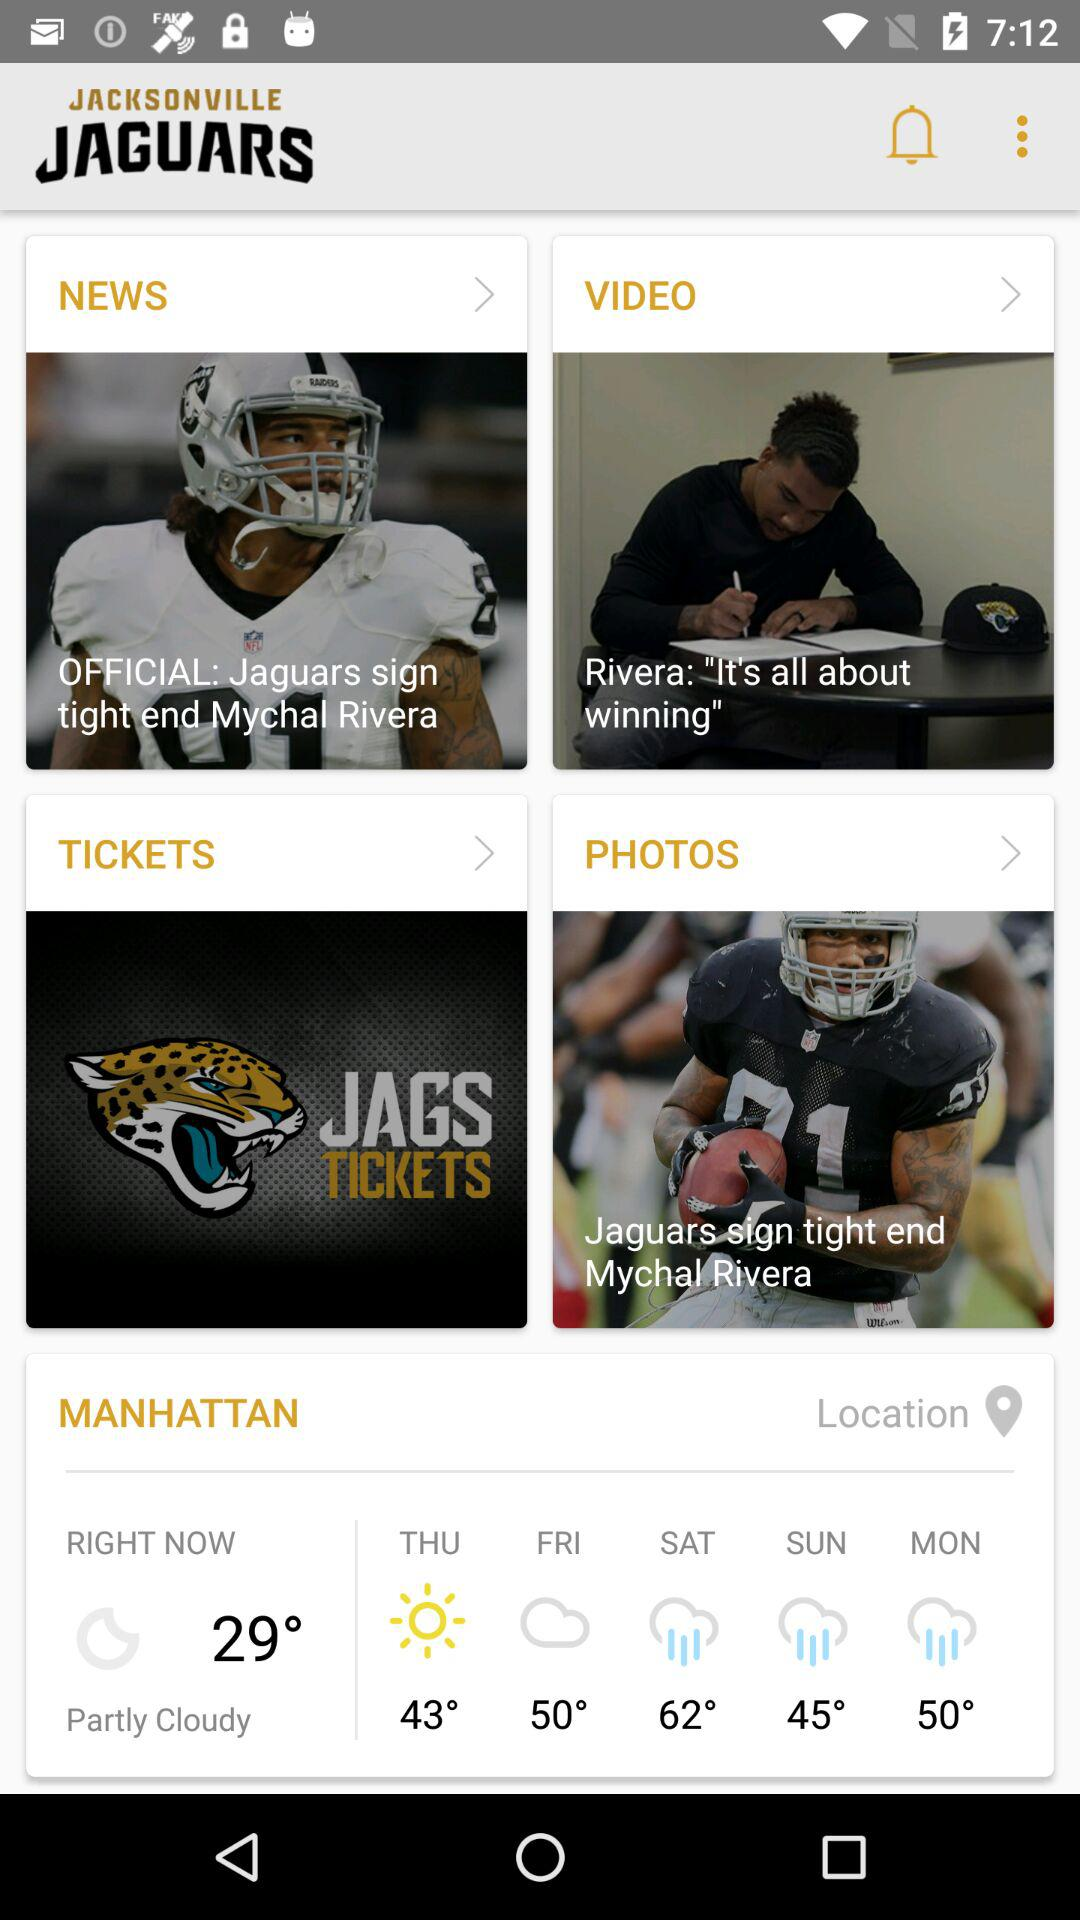What is the name of the application? The name of the application is "JACKSONVILLE JAGUARS". 